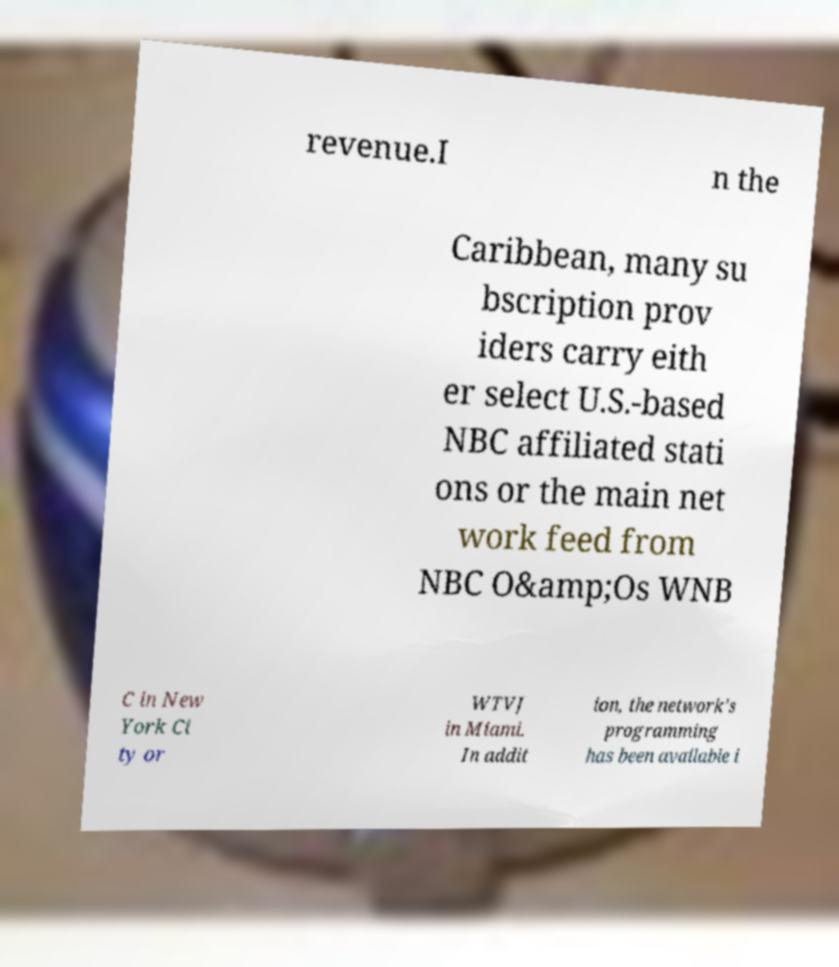I need the written content from this picture converted into text. Can you do that? revenue.I n the Caribbean, many su bscription prov iders carry eith er select U.S.-based NBC affiliated stati ons or the main net work feed from NBC O&amp;Os WNB C in New York Ci ty or WTVJ in Miami. In addit ion, the network's programming has been available i 